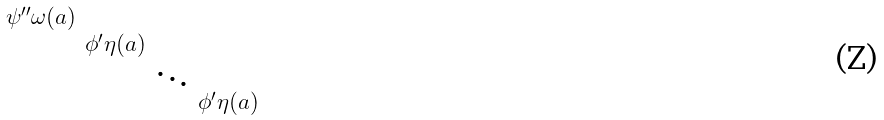Convert formula to latex. <formula><loc_0><loc_0><loc_500><loc_500>\begin{smallmatrix} \psi ^ { \prime \prime } \omega ( a ) & & & \\ & \phi ^ { \prime } \eta ( a ) & & \\ & & \ddots & \\ & & & \phi ^ { \prime } \eta ( a ) \end{smallmatrix}</formula> 